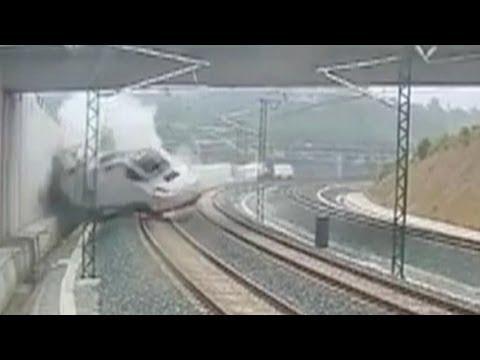Are the passengers of this vehicle relaxed?
Quick response, please. No. IS the trains on the tracks?
Keep it brief. No. What happened to the train?
Write a very short answer. Crashed. 